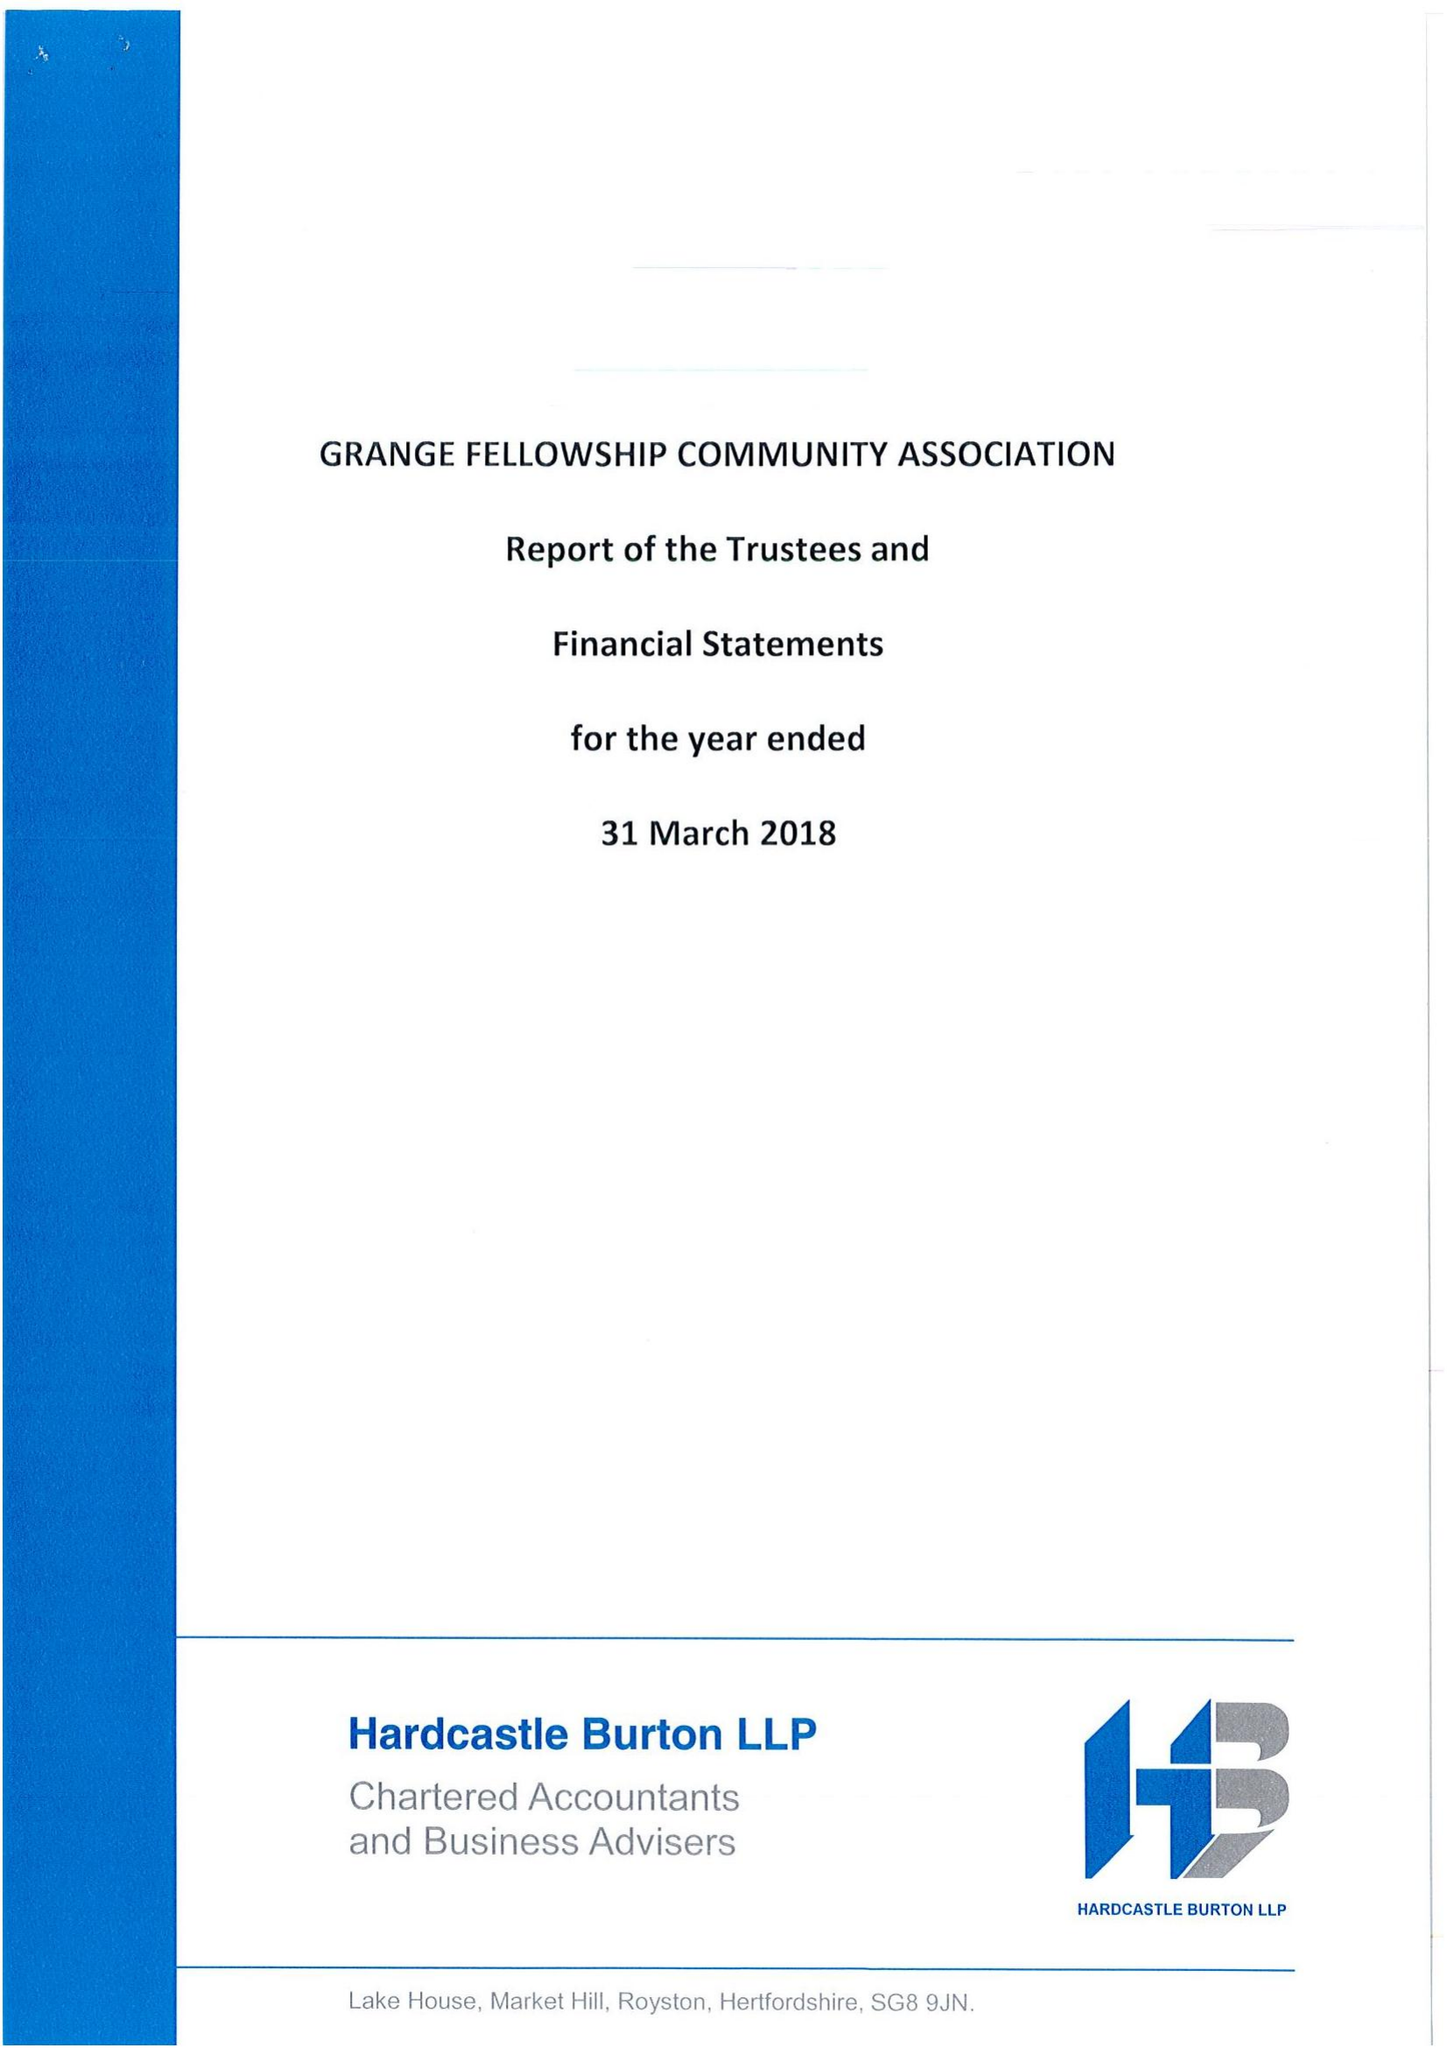What is the value for the report_date?
Answer the question using a single word or phrase. 2018-03-31 